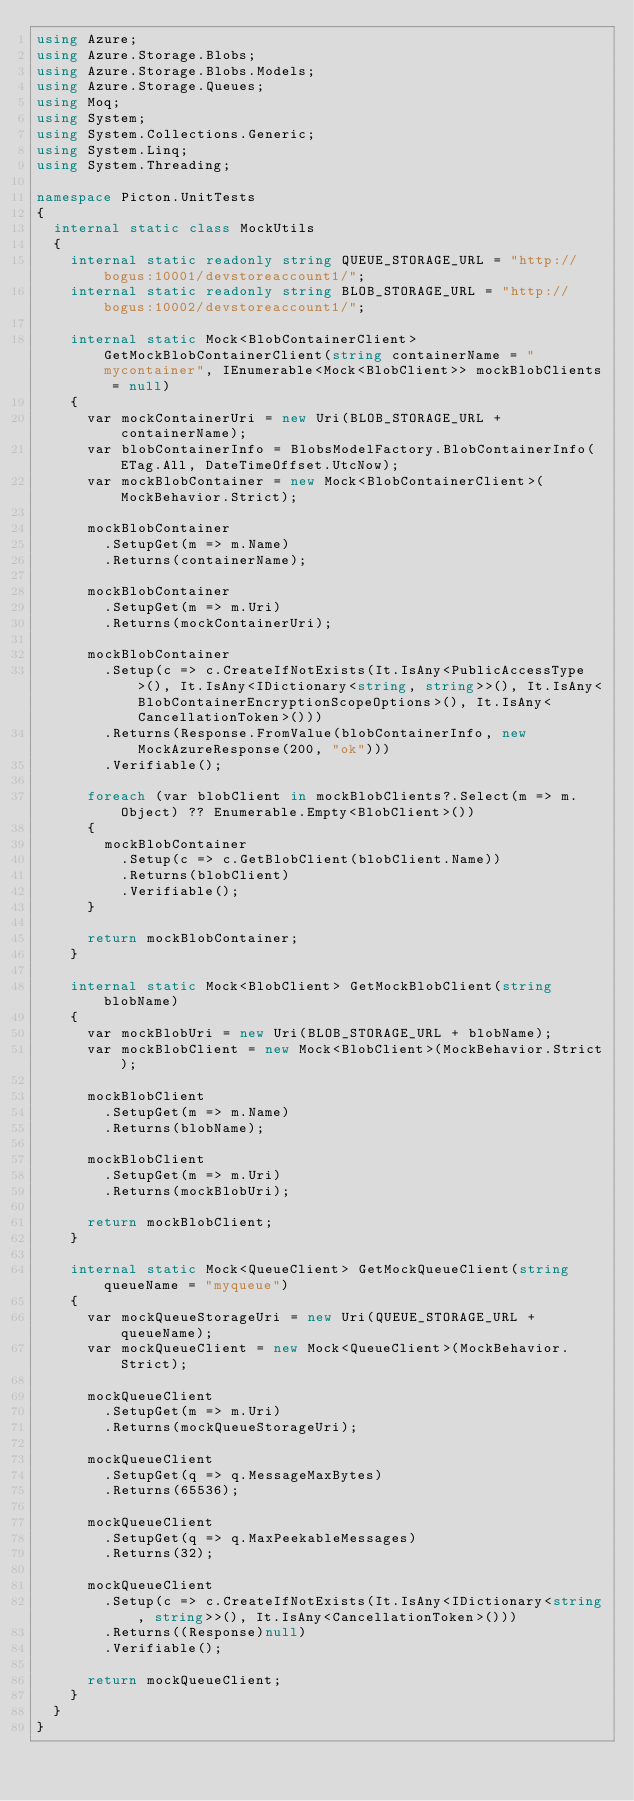Convert code to text. <code><loc_0><loc_0><loc_500><loc_500><_C#_>using Azure;
using Azure.Storage.Blobs;
using Azure.Storage.Blobs.Models;
using Azure.Storage.Queues;
using Moq;
using System;
using System.Collections.Generic;
using System.Linq;
using System.Threading;

namespace Picton.UnitTests
{
	internal static class MockUtils
	{
		internal static readonly string QUEUE_STORAGE_URL = "http://bogus:10001/devstoreaccount1/";
		internal static readonly string BLOB_STORAGE_URL = "http://bogus:10002/devstoreaccount1/";

		internal static Mock<BlobContainerClient> GetMockBlobContainerClient(string containerName = "mycontainer", IEnumerable<Mock<BlobClient>> mockBlobClients = null)
		{
			var mockContainerUri = new Uri(BLOB_STORAGE_URL + containerName);
			var blobContainerInfo = BlobsModelFactory.BlobContainerInfo(ETag.All, DateTimeOffset.UtcNow);
			var mockBlobContainer = new Mock<BlobContainerClient>(MockBehavior.Strict);

			mockBlobContainer
				.SetupGet(m => m.Name)
				.Returns(containerName);

			mockBlobContainer
				.SetupGet(m => m.Uri)
				.Returns(mockContainerUri);

			mockBlobContainer
				.Setup(c => c.CreateIfNotExists(It.IsAny<PublicAccessType>(), It.IsAny<IDictionary<string, string>>(), It.IsAny<BlobContainerEncryptionScopeOptions>(), It.IsAny<CancellationToken>()))
				.Returns(Response.FromValue(blobContainerInfo, new MockAzureResponse(200, "ok")))
				.Verifiable();

			foreach (var blobClient in mockBlobClients?.Select(m => m.Object) ?? Enumerable.Empty<BlobClient>())
			{
				mockBlobContainer
					.Setup(c => c.GetBlobClient(blobClient.Name))
					.Returns(blobClient)
					.Verifiable();
			}

			return mockBlobContainer;
		}

		internal static Mock<BlobClient> GetMockBlobClient(string blobName)
		{
			var mockBlobUri = new Uri(BLOB_STORAGE_URL + blobName);
			var mockBlobClient = new Mock<BlobClient>(MockBehavior.Strict);

			mockBlobClient
				.SetupGet(m => m.Name)
				.Returns(blobName);

			mockBlobClient
				.SetupGet(m => m.Uri)
				.Returns(mockBlobUri);

			return mockBlobClient;
		}

		internal static Mock<QueueClient> GetMockQueueClient(string queueName = "myqueue")
		{
			var mockQueueStorageUri = new Uri(QUEUE_STORAGE_URL + queueName);
			var mockQueueClient = new Mock<QueueClient>(MockBehavior.Strict);

			mockQueueClient
				.SetupGet(m => m.Uri)
				.Returns(mockQueueStorageUri);

			mockQueueClient
				.SetupGet(q => q.MessageMaxBytes)
				.Returns(65536);

			mockQueueClient
				.SetupGet(q => q.MaxPeekableMessages)
				.Returns(32);

			mockQueueClient
				.Setup(c => c.CreateIfNotExists(It.IsAny<IDictionary<string, string>>(), It.IsAny<CancellationToken>()))
				.Returns((Response)null)
				.Verifiable();

			return mockQueueClient;
		}
	}
}
</code> 